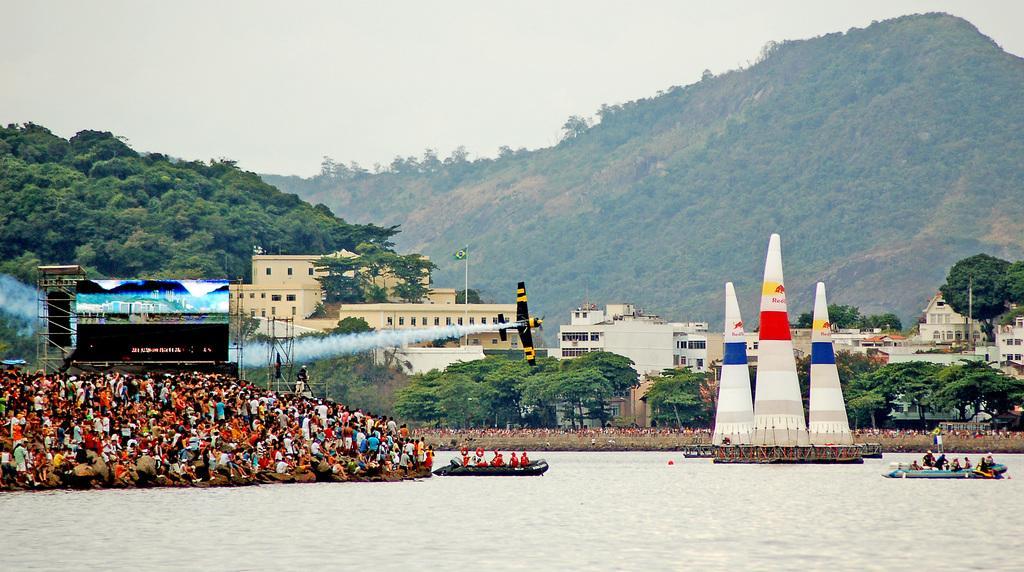Could you give a brief overview of what you see in this image? In the center of the image we can see the sky, trees, buildings, smoke, one airplane, hill, one screen, few boats on the water, few people and a few other objects. 